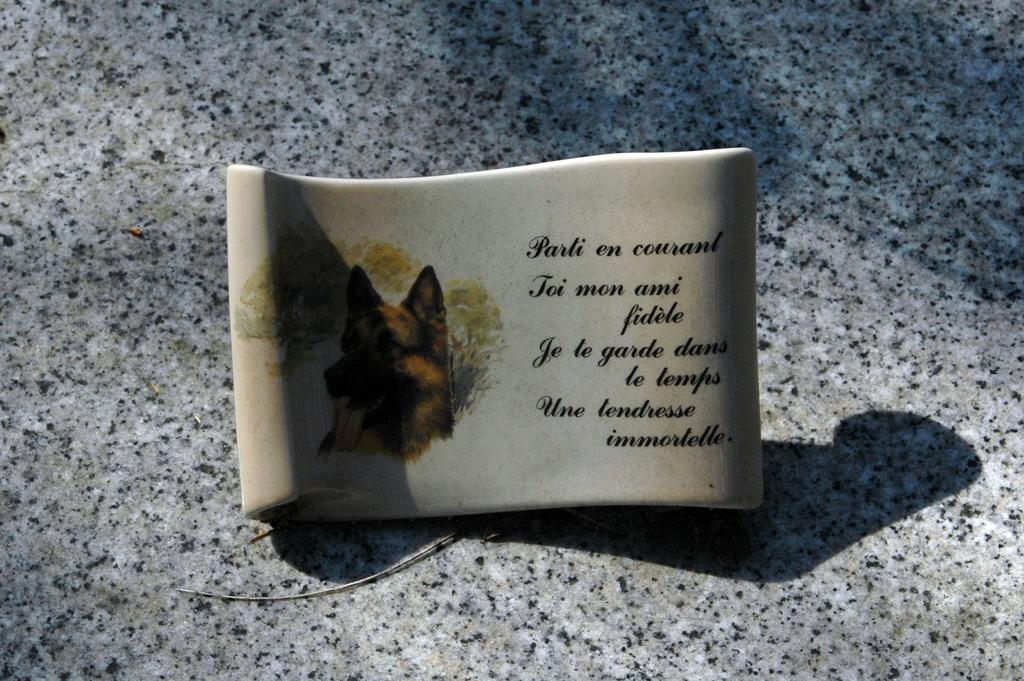What is the main subject of the image? There is a picture of a dog in the image. What else can be seen in the image besides the dog? There is text written on a ceramic stone in the image. Where is the ceramic stone located in the image? The ceramic stone is in the middle of the image. What is visible in the background of the image? There is a floor visible in the background of the image. What type of government is depicted in the image? There is no depiction of a government in the image; it features a picture of a dog and a ceramic stone with text. How hot is the dog in the image? The image does not provide information about the temperature of the dog, so it cannot be determined. 